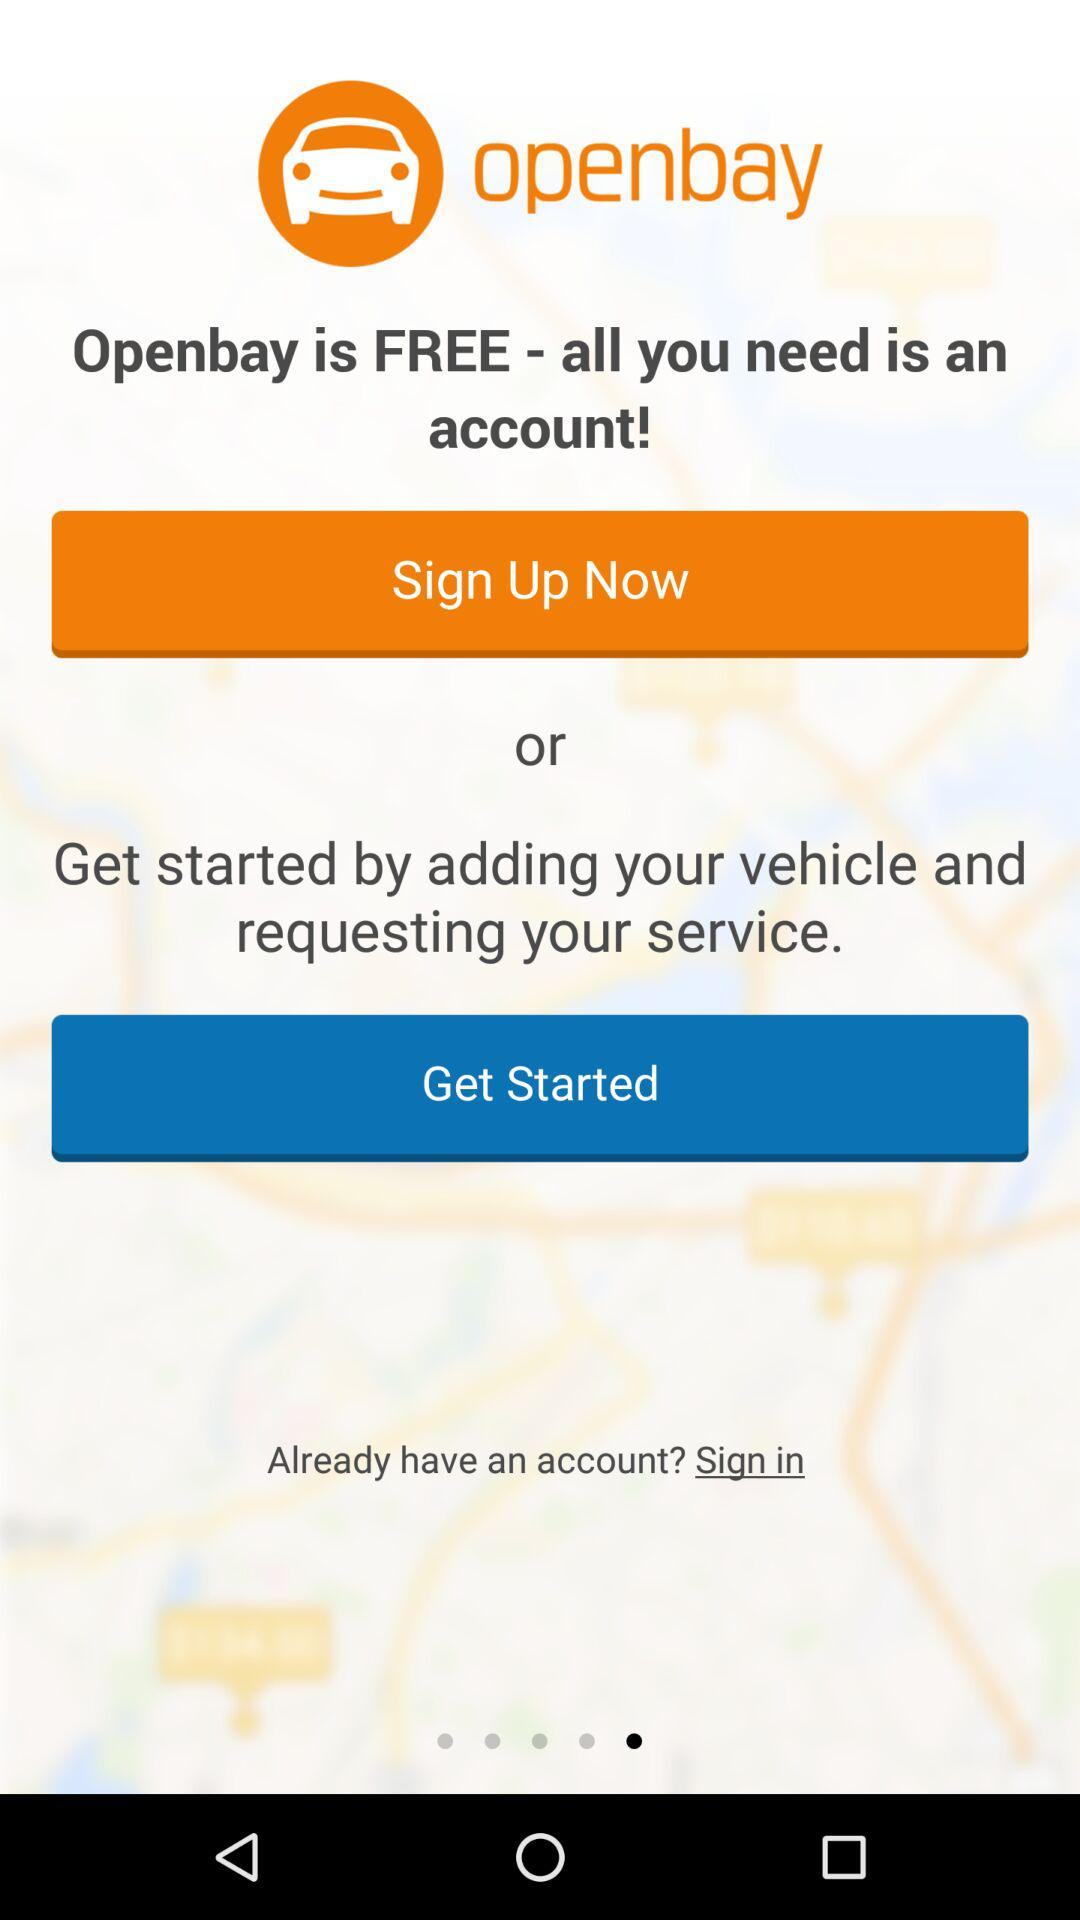What details are needed? The detail needed is "account". 